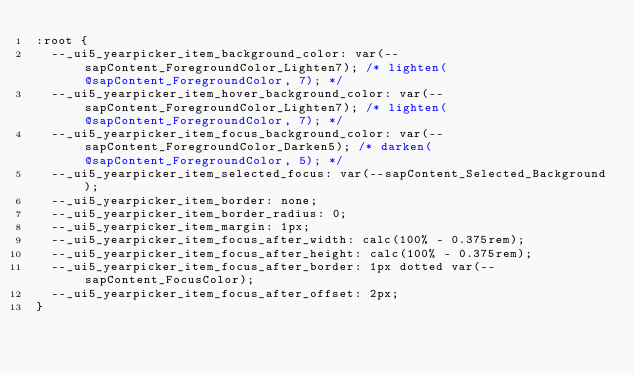<code> <loc_0><loc_0><loc_500><loc_500><_CSS_>:root {
	--_ui5_yearpicker_item_background_color: var(--sapContent_ForegroundColor_Lighten7); /* lighten(@sapContent_ForegroundColor, 7); */
	--_ui5_yearpicker_item_hover_background_color: var(--sapContent_ForegroundColor_Lighten7); /* lighten(@sapContent_ForegroundColor, 7); */
	--_ui5_yearpicker_item_focus_background_color: var(--sapContent_ForegroundColor_Darken5); /* darken(@sapContent_ForegroundColor, 5); */
	--_ui5_yearpicker_item_selected_focus: var(--sapContent_Selected_Background);
	--_ui5_yearpicker_item_border: none;
	--_ui5_yearpicker_item_border_radius: 0;
	--_ui5_yearpicker_item_margin: 1px;
	--_ui5_yearpicker_item_focus_after_width: calc(100% - 0.375rem);
	--_ui5_yearpicker_item_focus_after_height: calc(100% - 0.375rem);
	--_ui5_yearpicker_item_focus_after_border: 1px dotted var(--sapContent_FocusColor);
	--_ui5_yearpicker_item_focus_after_offset: 2px;
}</code> 